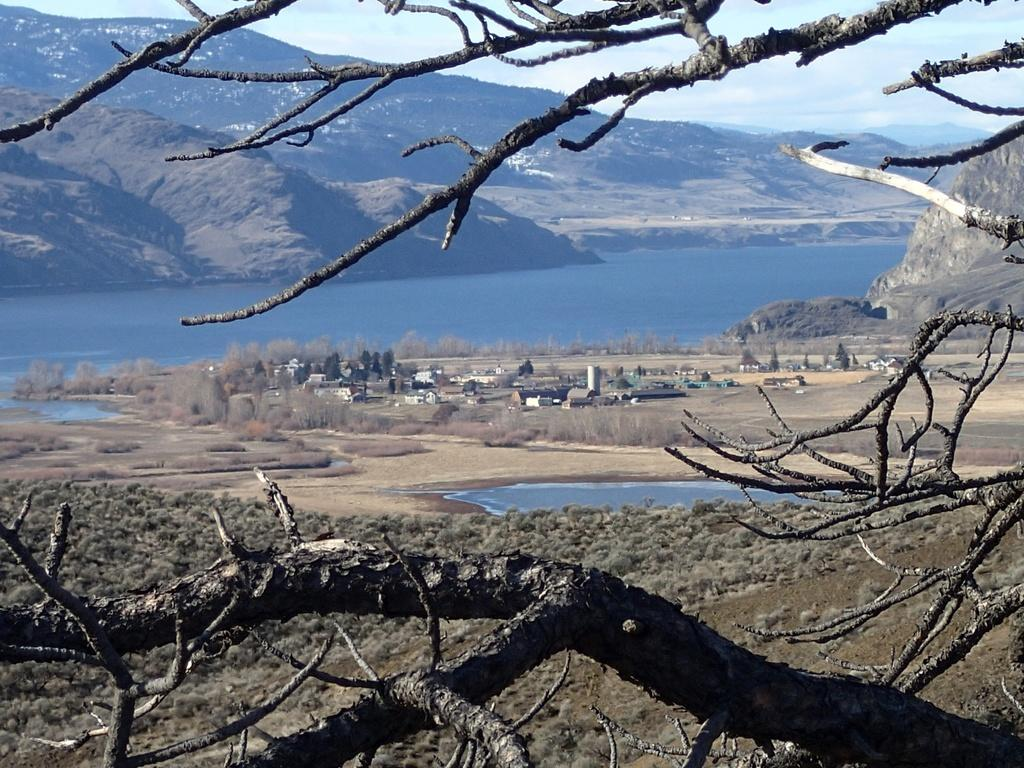What type of natural elements can be seen in the image? There are branches of trees and trees visible in the image. What type of man-made structures can be seen in the image? There are buildings visible in the image. What type of natural feature can be seen in the image? There is water visible in the image. What type of landscape feature can be seen in the background of the image? There are mountains in the background of the image. What part of the sky is visible in the background of the image? The sky is visible in the background of the image. What type of scarf is being used to hold the button in the image? There is no scarf or button present in the image. What time of day is it in the image, considering the presence of the afternoon? The image does not provide any information about the time of day, and there is no mention of an afternoon. 